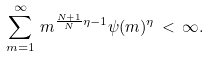Convert formula to latex. <formula><loc_0><loc_0><loc_500><loc_500>\sum _ { m = 1 } ^ { \infty } \, m ^ { \frac { N + 1 } N \eta - 1 } \psi ( m ) ^ { \eta } \, < \, \infty .</formula> 